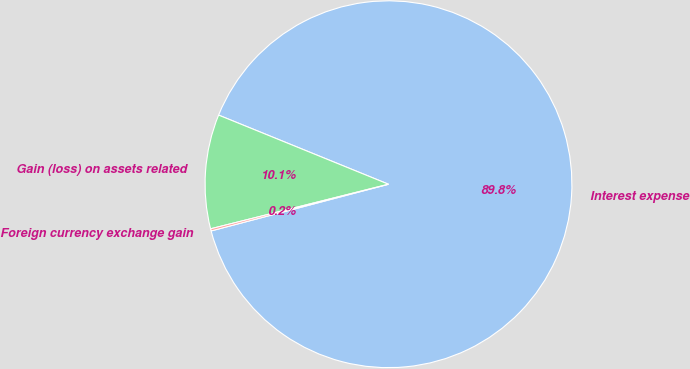<chart> <loc_0><loc_0><loc_500><loc_500><pie_chart><fcel>Interest expense<fcel>Gain (loss) on assets related<fcel>Foreign currency exchange gain<nl><fcel>89.75%<fcel>10.06%<fcel>0.19%<nl></chart> 